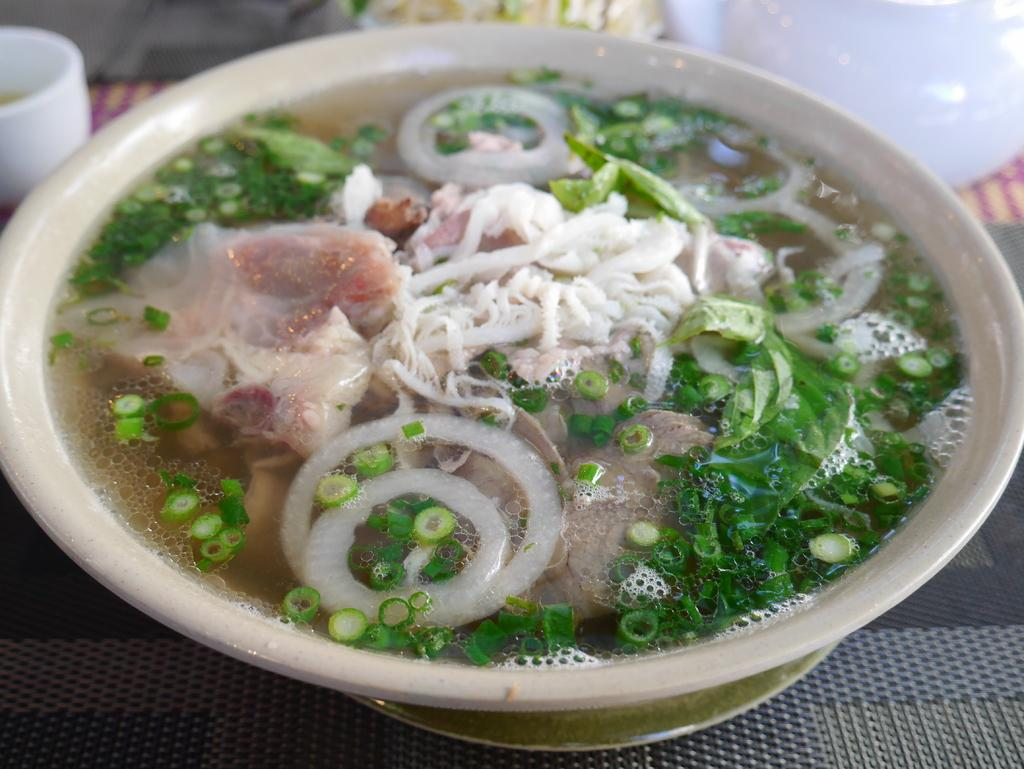What is the main food item in the image? There is a food item in a bowl in the image. Can you describe any other objects in the image? There is a cup in the top left of the image. How many toes are visible in the image? There are no toes visible in the image. What type of sink is present in the image? There is no sink present in the image. 